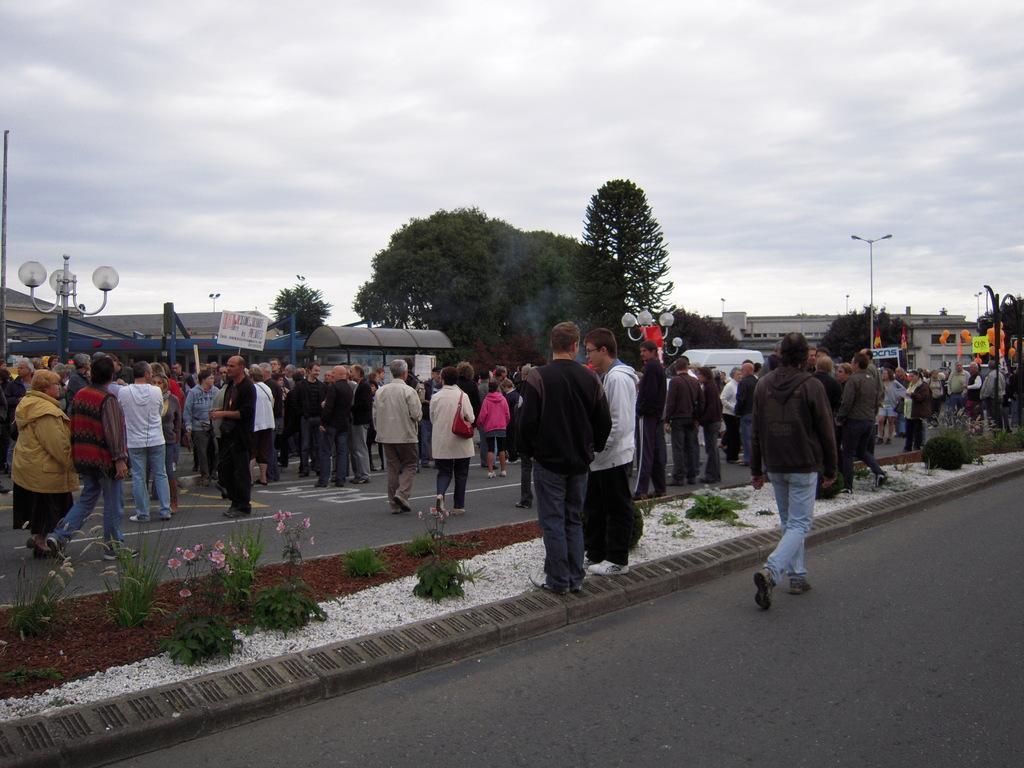Please provide a concise description of this image. In this image we can see there are few people walking on the road and few are standing at the center of the road and there are a few plants and there is a street light to a side of a road. In the background there are buildings, trees and sky. 